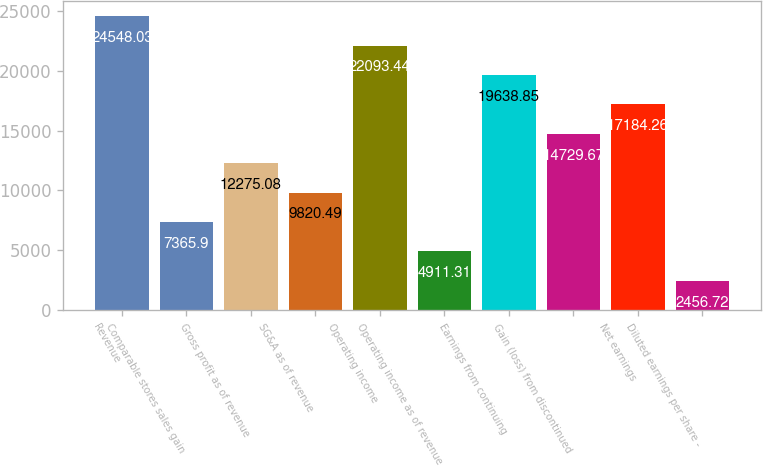<chart> <loc_0><loc_0><loc_500><loc_500><bar_chart><fcel>Revenue<fcel>Comparable stores sales gain<fcel>Gross profit as of revenue<fcel>SG&A as of revenue<fcel>Operating income<fcel>Operating income as of revenue<fcel>Earnings from continuing<fcel>Gain (loss) from discontinued<fcel>Net earnings<fcel>Diluted earnings per share -<nl><fcel>24548<fcel>7365.9<fcel>12275.1<fcel>9820.49<fcel>22093.4<fcel>4911.31<fcel>19638.8<fcel>14729.7<fcel>17184.3<fcel>2456.72<nl></chart> 